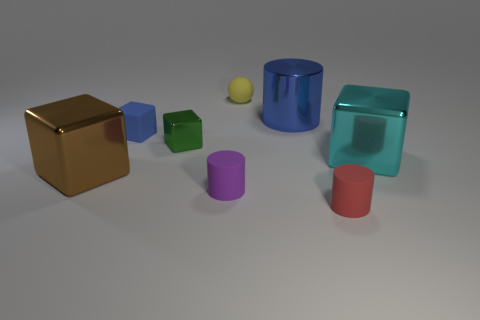Is the shape of the small blue matte object the same as the small yellow object?
Your answer should be very brief. No. Are there any other things that have the same material as the tiny yellow ball?
Offer a very short reply. Yes. What number of objects are both on the right side of the big brown shiny object and left of the big blue metal object?
Keep it short and to the point. 4. There is a small cylinder to the left of the blue object that is behind the small blue object; what color is it?
Your response must be concise. Purple. Are there an equal number of blue matte objects on the left side of the matte block and big cyan cubes?
Your answer should be compact. No. There is a blue object that is to the left of the small matte cylinder left of the red cylinder; how many big blue metallic cylinders are behind it?
Keep it short and to the point. 1. What color is the small cylinder that is to the right of the tiny yellow rubber object?
Keep it short and to the point. Red. What is the material of the cube that is on the left side of the small yellow matte object and right of the small blue matte thing?
Your answer should be very brief. Metal. What number of blue matte blocks are on the left side of the tiny rubber object that is on the left side of the tiny purple thing?
Make the answer very short. 0. What shape is the red rubber thing?
Provide a short and direct response. Cylinder. 